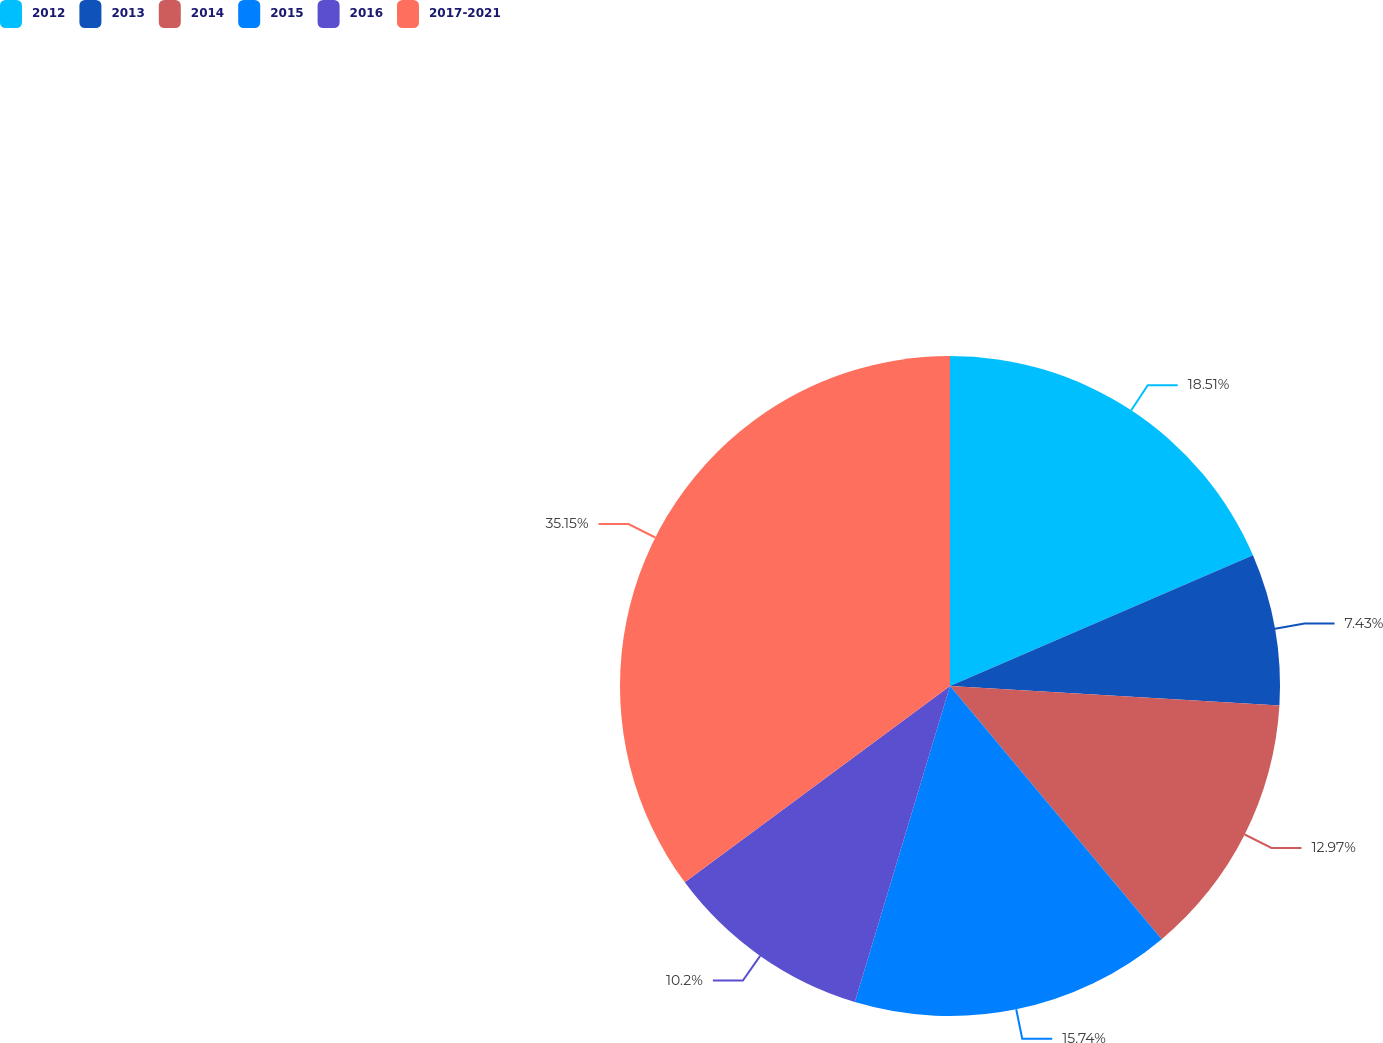Convert chart to OTSL. <chart><loc_0><loc_0><loc_500><loc_500><pie_chart><fcel>2012<fcel>2013<fcel>2014<fcel>2015<fcel>2016<fcel>2017-2021<nl><fcel>18.51%<fcel>7.43%<fcel>12.97%<fcel>15.74%<fcel>10.2%<fcel>35.14%<nl></chart> 